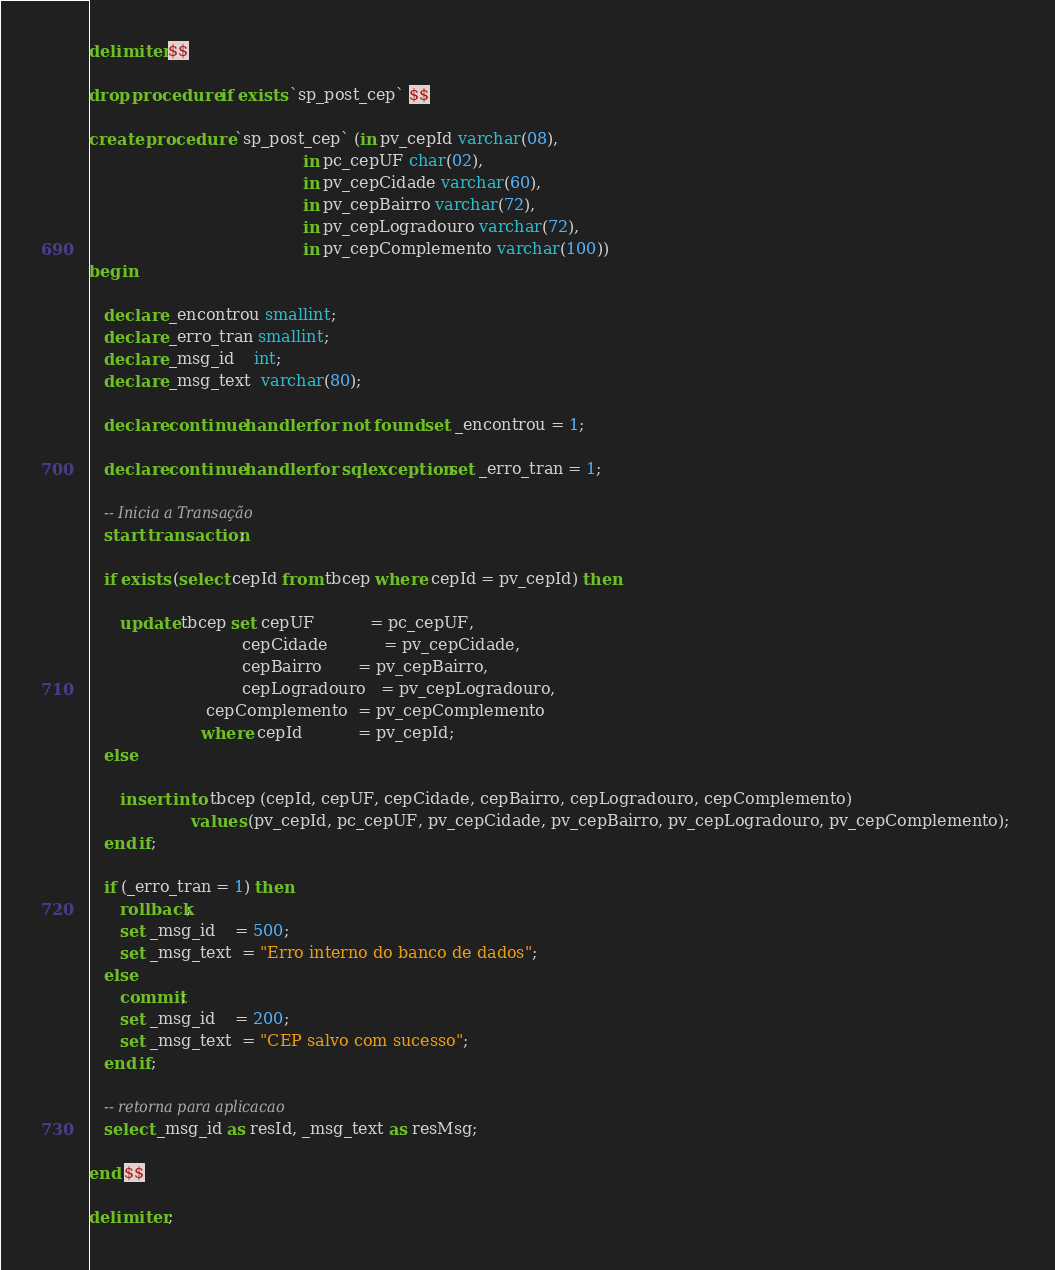Convert code to text. <code><loc_0><loc_0><loc_500><loc_500><_SQL_>
delimiter $$

drop procedure if exists `sp_post_cep` $$

create procedure `sp_post_cep` (in pv_cepId varchar(08), 
										  in pc_cepUF char(02), 
										  in pv_cepCidade varchar(60),
										  in pv_cepBairro varchar(72), 
										  in pv_cepLogradouro varchar(72),
										  in pv_cepComplemento varchar(100)) 
begin
   
   declare _encontrou smallint;
   declare _erro_tran smallint;
   declare _msg_id    int;
   declare _msg_text  varchar(80);

   declare continue handler for not found set _encontrou = 1; 
    
   declare continue handler for sqlexception set _erro_tran = 1;  
   
   -- Inicia a Transação
   start transaction; 
   
   if exists (select cepId from tbcep where cepId = pv_cepId) then

      update tbcep set cepUF           = pc_cepUF, 
							  cepCidade		   = pv_cepCidade,
							  cepBairro       = pv_cepBairro, 
							  cepLogradouro   = pv_cepLogradouro,
                       cepComplemento  = pv_cepComplemento
					  where cepId           = pv_cepId;      
   else
			
      insert into tbcep (cepId, cepUF, cepCidade, cepBairro, cepLogradouro, cepComplemento) 
			        values (pv_cepId, pc_cepUF, pv_cepCidade, pv_cepBairro, pv_cepLogradouro, pv_cepComplemento); 
   end if;
  	
   if (_erro_tran = 1) then
      rollback; 
      set _msg_id    = 500;
      set _msg_text  = "Erro interno do banco de dados";
   else
      commit; 
      set _msg_id    = 200;
      set _msg_text  = "CEP salvo com sucesso";
   end if; 
   
   -- retorna para aplicacao
   select _msg_id as resId, _msg_text as resMsg;
   
end $$

delimiter ;</code> 